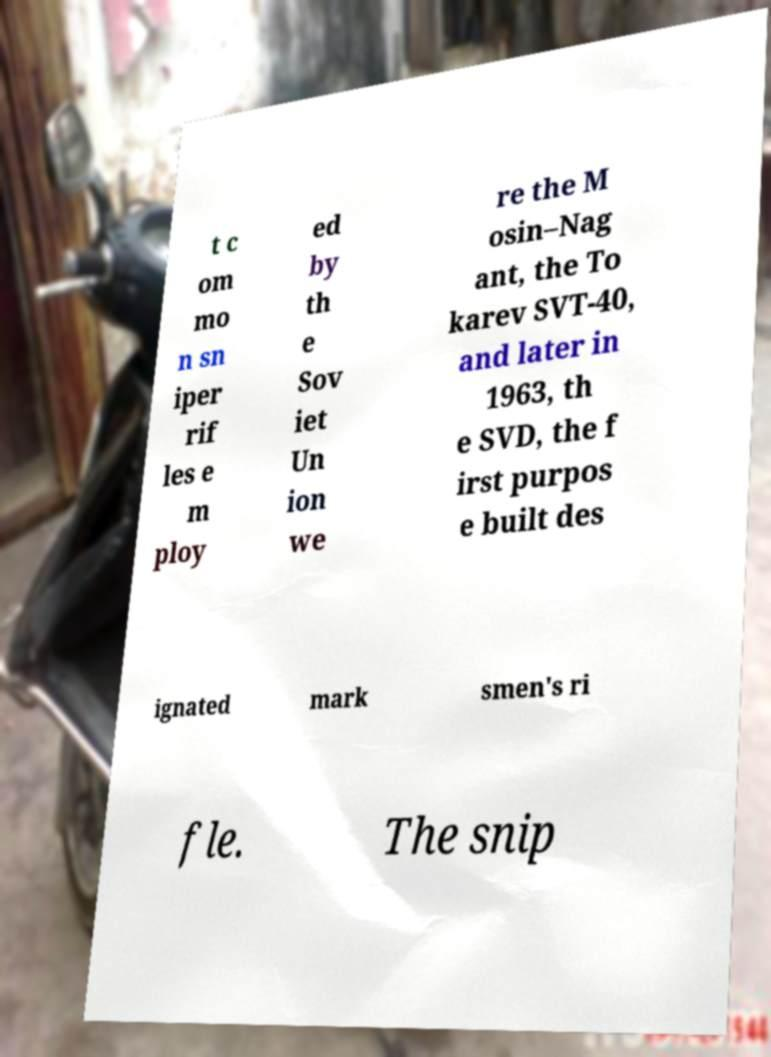I need the written content from this picture converted into text. Can you do that? t c om mo n sn iper rif les e m ploy ed by th e Sov iet Un ion we re the M osin–Nag ant, the To karev SVT-40, and later in 1963, th e SVD, the f irst purpos e built des ignated mark smen's ri fle. The snip 